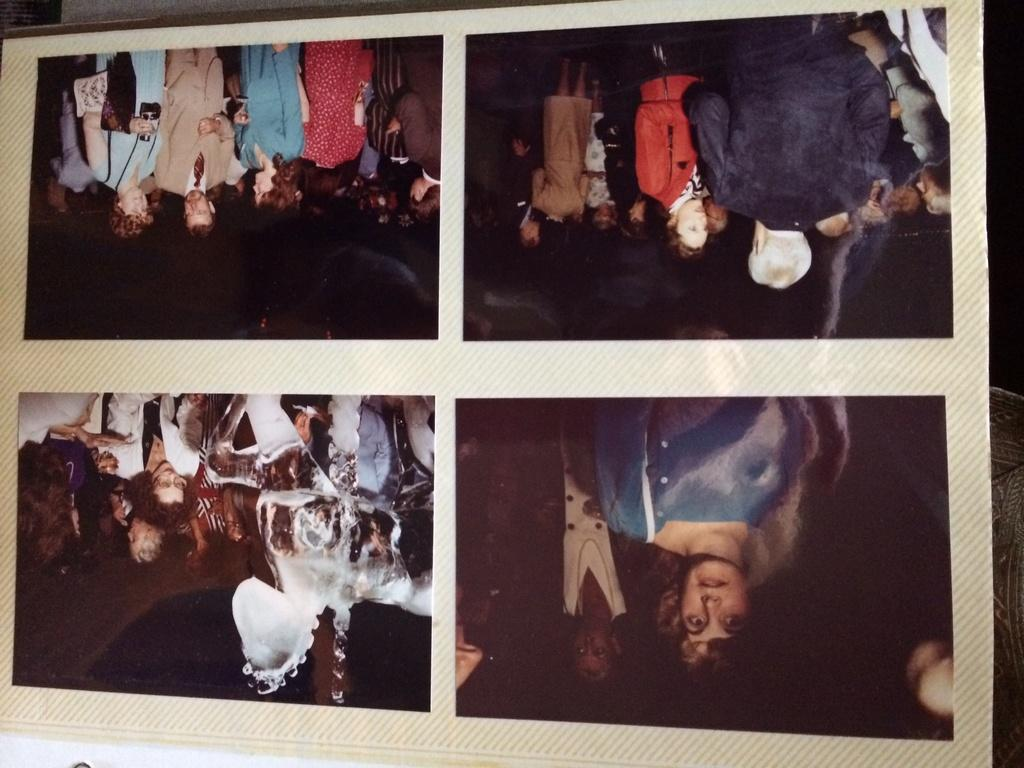What is the main object in the image? There is an album in the image. What can be found inside the album? The album contains four photographs. Are there any wheels visible in the image? No, there are no wheels present in the image. Can you see any cobwebs in the image? No, there are no cobwebs present in the image. 